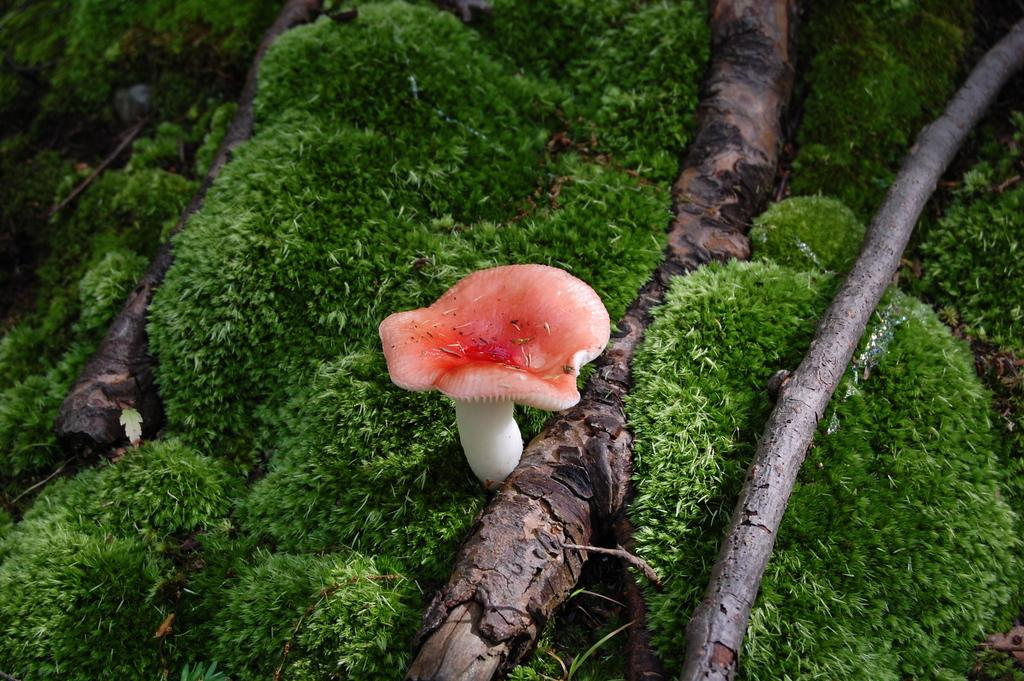What is the main subject in the center of the image? There is a mushroom in the center of the image. Where is the mushroom located? The mushroom is on the ground. What type of beast is sitting on the tray in the image? There is no tray or beast present in the image; it only features a mushroom on the ground. 